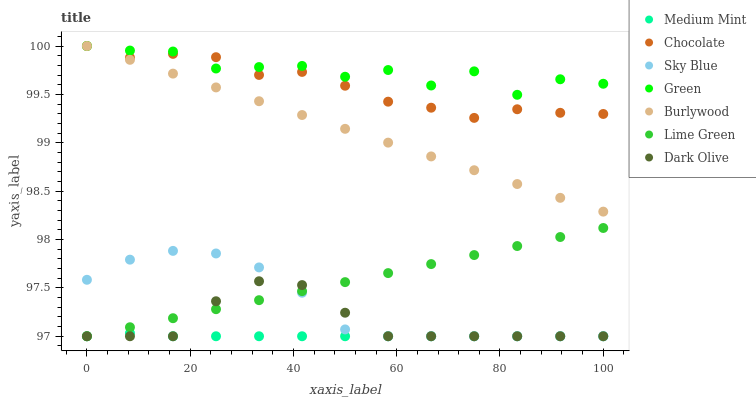Does Medium Mint have the minimum area under the curve?
Answer yes or no. Yes. Does Green have the maximum area under the curve?
Answer yes or no. Yes. Does Burlywood have the minimum area under the curve?
Answer yes or no. No. Does Burlywood have the maximum area under the curve?
Answer yes or no. No. Is Burlywood the smoothest?
Answer yes or no. Yes. Is Green the roughest?
Answer yes or no. Yes. Is Dark Olive the smoothest?
Answer yes or no. No. Is Dark Olive the roughest?
Answer yes or no. No. Does Medium Mint have the lowest value?
Answer yes or no. Yes. Does Burlywood have the lowest value?
Answer yes or no. No. Does Green have the highest value?
Answer yes or no. Yes. Does Dark Olive have the highest value?
Answer yes or no. No. Is Sky Blue less than Burlywood?
Answer yes or no. Yes. Is Chocolate greater than Lime Green?
Answer yes or no. Yes. Does Chocolate intersect Burlywood?
Answer yes or no. Yes. Is Chocolate less than Burlywood?
Answer yes or no. No. Is Chocolate greater than Burlywood?
Answer yes or no. No. Does Sky Blue intersect Burlywood?
Answer yes or no. No. 